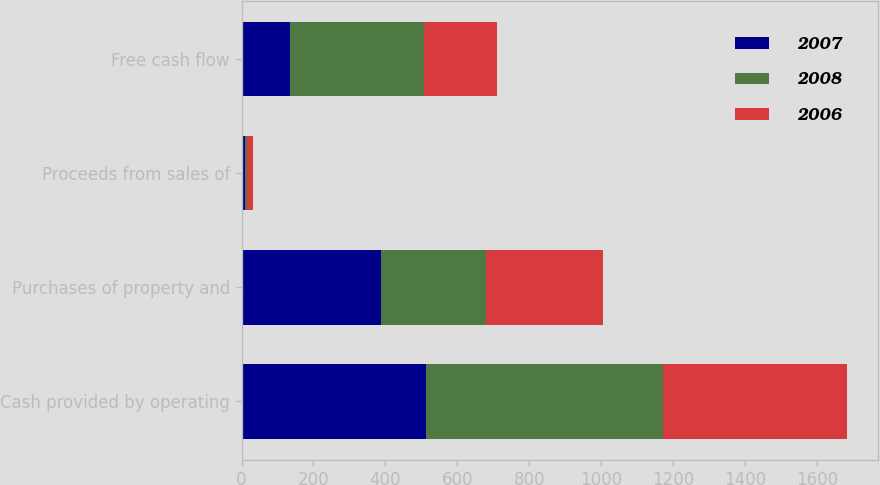Convert chart to OTSL. <chart><loc_0><loc_0><loc_500><loc_500><stacked_bar_chart><ecel><fcel>Cash provided by operating<fcel>Purchases of property and<fcel>Proceeds from sales of<fcel>Free cash flow<nl><fcel>2007<fcel>512.2<fcel>386.9<fcel>8.2<fcel>133.5<nl><fcel>2008<fcel>661.3<fcel>292.5<fcel>6.1<fcel>374.9<nl><fcel>2006<fcel>511.2<fcel>326.7<fcel>18.5<fcel>203<nl></chart> 